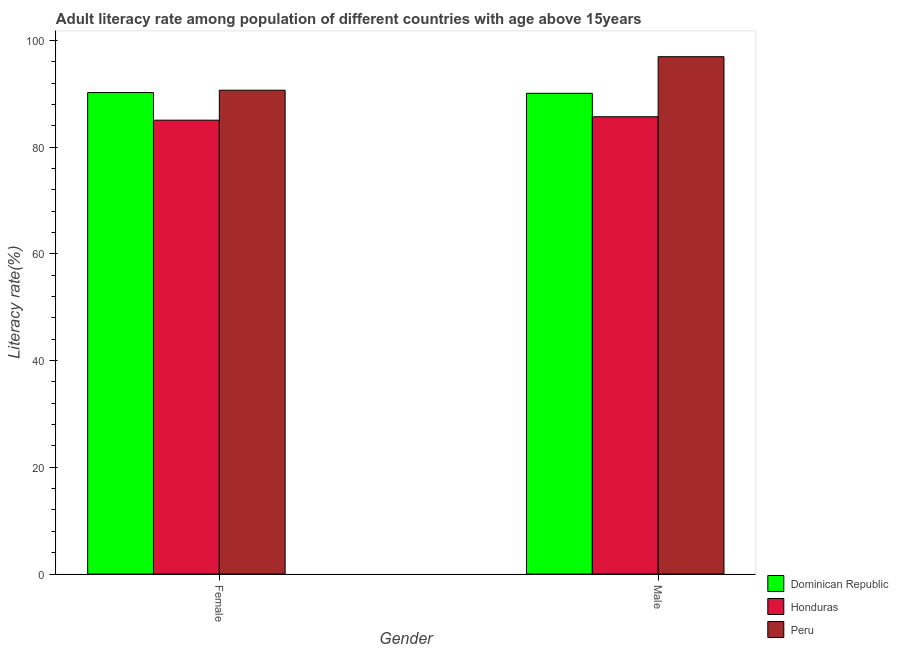How many groups of bars are there?
Provide a short and direct response. 2. Are the number of bars on each tick of the X-axis equal?
Give a very brief answer. Yes. How many bars are there on the 1st tick from the left?
Make the answer very short. 3. What is the male adult literacy rate in Dominican Republic?
Ensure brevity in your answer.  90.08. Across all countries, what is the maximum female adult literacy rate?
Provide a succinct answer. 90.67. Across all countries, what is the minimum female adult literacy rate?
Provide a succinct answer. 85.05. In which country was the female adult literacy rate maximum?
Offer a terse response. Peru. In which country was the female adult literacy rate minimum?
Your answer should be very brief. Honduras. What is the total female adult literacy rate in the graph?
Provide a short and direct response. 265.94. What is the difference between the female adult literacy rate in Honduras and that in Dominican Republic?
Provide a short and direct response. -5.17. What is the difference between the female adult literacy rate in Peru and the male adult literacy rate in Honduras?
Provide a succinct answer. 4.97. What is the average male adult literacy rate per country?
Your answer should be very brief. 90.91. What is the difference between the female adult literacy rate and male adult literacy rate in Dominican Republic?
Ensure brevity in your answer.  0.14. What is the ratio of the female adult literacy rate in Peru to that in Dominican Republic?
Offer a very short reply. 1. Is the female adult literacy rate in Honduras less than that in Dominican Republic?
Offer a very short reply. Yes. What does the 1st bar from the left in Male represents?
Your response must be concise. Dominican Republic. What does the 3rd bar from the right in Female represents?
Make the answer very short. Dominican Republic. How many bars are there?
Give a very brief answer. 6. Are all the bars in the graph horizontal?
Provide a succinct answer. No. Are the values on the major ticks of Y-axis written in scientific E-notation?
Provide a short and direct response. No. Does the graph contain any zero values?
Your answer should be very brief. No. Does the graph contain grids?
Give a very brief answer. No. How many legend labels are there?
Ensure brevity in your answer.  3. What is the title of the graph?
Ensure brevity in your answer.  Adult literacy rate among population of different countries with age above 15years. Does "Lesotho" appear as one of the legend labels in the graph?
Offer a terse response. No. What is the label or title of the Y-axis?
Ensure brevity in your answer.  Literacy rate(%). What is the Literacy rate(%) of Dominican Republic in Female?
Provide a succinct answer. 90.22. What is the Literacy rate(%) of Honduras in Female?
Ensure brevity in your answer.  85.05. What is the Literacy rate(%) of Peru in Female?
Ensure brevity in your answer.  90.67. What is the Literacy rate(%) in Dominican Republic in Male?
Provide a short and direct response. 90.08. What is the Literacy rate(%) in Honduras in Male?
Give a very brief answer. 85.7. What is the Literacy rate(%) in Peru in Male?
Make the answer very short. 96.95. Across all Gender, what is the maximum Literacy rate(%) in Dominican Republic?
Make the answer very short. 90.22. Across all Gender, what is the maximum Literacy rate(%) of Honduras?
Provide a short and direct response. 85.7. Across all Gender, what is the maximum Literacy rate(%) of Peru?
Give a very brief answer. 96.95. Across all Gender, what is the minimum Literacy rate(%) of Dominican Republic?
Ensure brevity in your answer.  90.08. Across all Gender, what is the minimum Literacy rate(%) in Honduras?
Ensure brevity in your answer.  85.05. Across all Gender, what is the minimum Literacy rate(%) in Peru?
Your answer should be compact. 90.67. What is the total Literacy rate(%) of Dominican Republic in the graph?
Your answer should be very brief. 180.31. What is the total Literacy rate(%) in Honduras in the graph?
Make the answer very short. 170.75. What is the total Literacy rate(%) in Peru in the graph?
Provide a succinct answer. 187.62. What is the difference between the Literacy rate(%) in Dominican Republic in Female and that in Male?
Provide a succinct answer. 0.14. What is the difference between the Literacy rate(%) in Honduras in Female and that in Male?
Provide a short and direct response. -0.64. What is the difference between the Literacy rate(%) of Peru in Female and that in Male?
Offer a terse response. -6.28. What is the difference between the Literacy rate(%) of Dominican Republic in Female and the Literacy rate(%) of Honduras in Male?
Offer a terse response. 4.53. What is the difference between the Literacy rate(%) in Dominican Republic in Female and the Literacy rate(%) in Peru in Male?
Give a very brief answer. -6.73. What is the difference between the Literacy rate(%) of Honduras in Female and the Literacy rate(%) of Peru in Male?
Provide a short and direct response. -11.9. What is the average Literacy rate(%) of Dominican Republic per Gender?
Provide a succinct answer. 90.15. What is the average Literacy rate(%) in Honduras per Gender?
Offer a terse response. 85.37. What is the average Literacy rate(%) of Peru per Gender?
Your answer should be very brief. 93.81. What is the difference between the Literacy rate(%) in Dominican Republic and Literacy rate(%) in Honduras in Female?
Offer a very short reply. 5.17. What is the difference between the Literacy rate(%) in Dominican Republic and Literacy rate(%) in Peru in Female?
Your answer should be compact. -0.44. What is the difference between the Literacy rate(%) of Honduras and Literacy rate(%) of Peru in Female?
Keep it short and to the point. -5.62. What is the difference between the Literacy rate(%) of Dominican Republic and Literacy rate(%) of Honduras in Male?
Ensure brevity in your answer.  4.39. What is the difference between the Literacy rate(%) in Dominican Republic and Literacy rate(%) in Peru in Male?
Ensure brevity in your answer.  -6.87. What is the difference between the Literacy rate(%) in Honduras and Literacy rate(%) in Peru in Male?
Offer a terse response. -11.25. What is the ratio of the Literacy rate(%) in Dominican Republic in Female to that in Male?
Give a very brief answer. 1. What is the ratio of the Literacy rate(%) in Honduras in Female to that in Male?
Your answer should be very brief. 0.99. What is the ratio of the Literacy rate(%) in Peru in Female to that in Male?
Make the answer very short. 0.94. What is the difference between the highest and the second highest Literacy rate(%) of Dominican Republic?
Your response must be concise. 0.14. What is the difference between the highest and the second highest Literacy rate(%) of Honduras?
Keep it short and to the point. 0.64. What is the difference between the highest and the second highest Literacy rate(%) in Peru?
Offer a very short reply. 6.28. What is the difference between the highest and the lowest Literacy rate(%) in Dominican Republic?
Ensure brevity in your answer.  0.14. What is the difference between the highest and the lowest Literacy rate(%) of Honduras?
Offer a very short reply. 0.64. What is the difference between the highest and the lowest Literacy rate(%) in Peru?
Give a very brief answer. 6.28. 